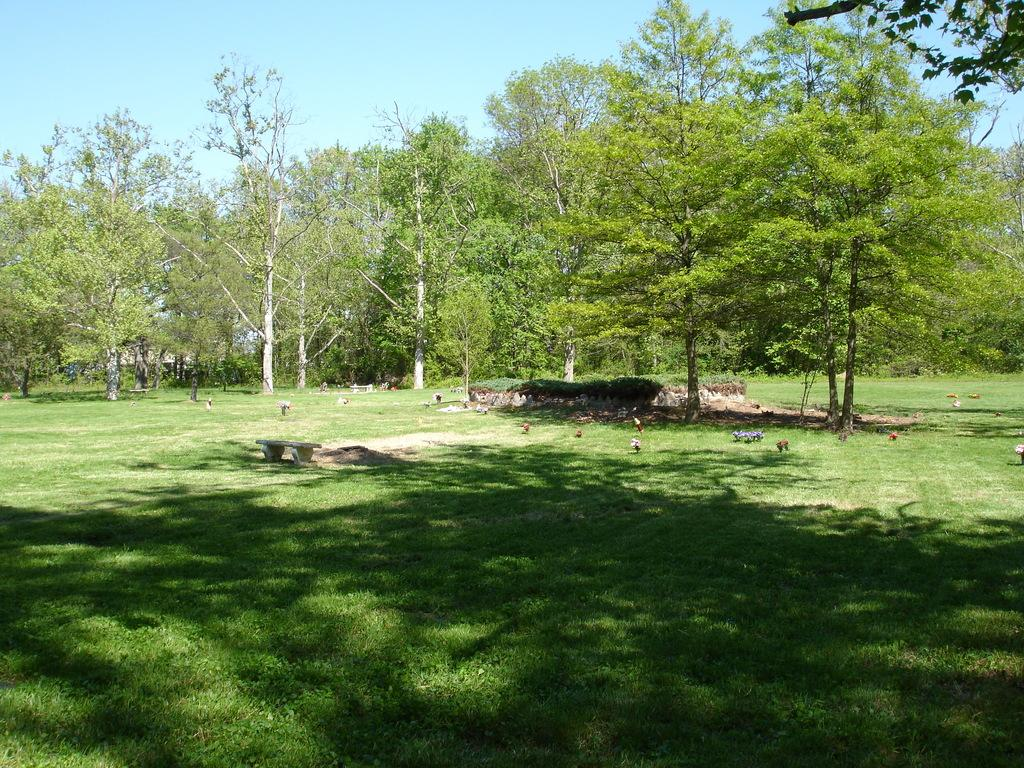What type of vegetation is present at the front of the image? There is grass in front of the image. What object is located in the center of the image? There is a bench in the center of the image. What can be seen in the background of the image? There are trees and the sky visible in the background of the image. How many clocks are hanging from the trees in the background? There are no clocks hanging from the trees in the image; only trees and the sky are visible in the background. Is there a masked figure sitting on the bench in the image? There is no masked figure present in the image; only the bench is visible in the center of the image. 